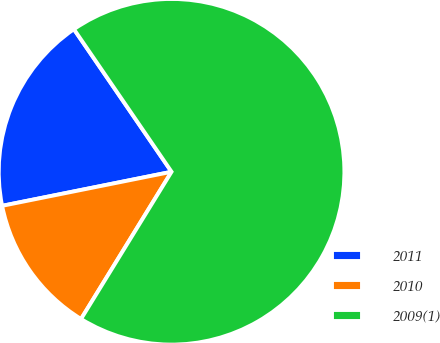Convert chart to OTSL. <chart><loc_0><loc_0><loc_500><loc_500><pie_chart><fcel>2011<fcel>2010<fcel>2009(1)<nl><fcel>18.6%<fcel>13.07%<fcel>68.33%<nl></chart> 